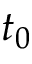<formula> <loc_0><loc_0><loc_500><loc_500>t _ { 0 }</formula> 